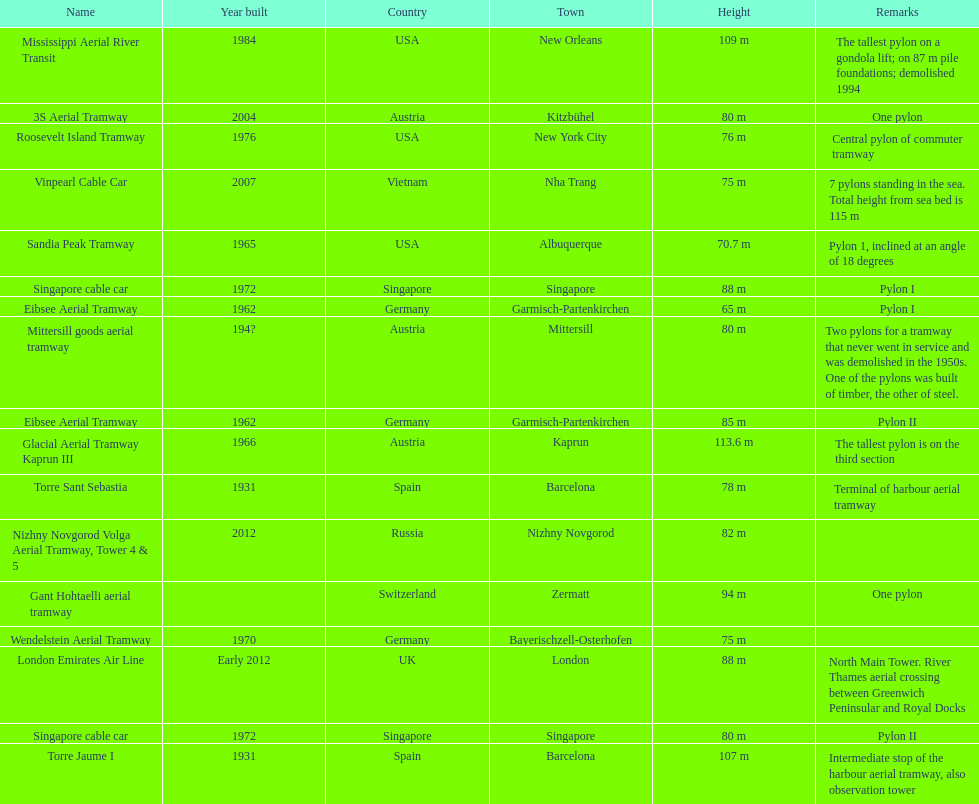The london emirates air line pylon shares an identical height with which pylon? Singapore cable car. 